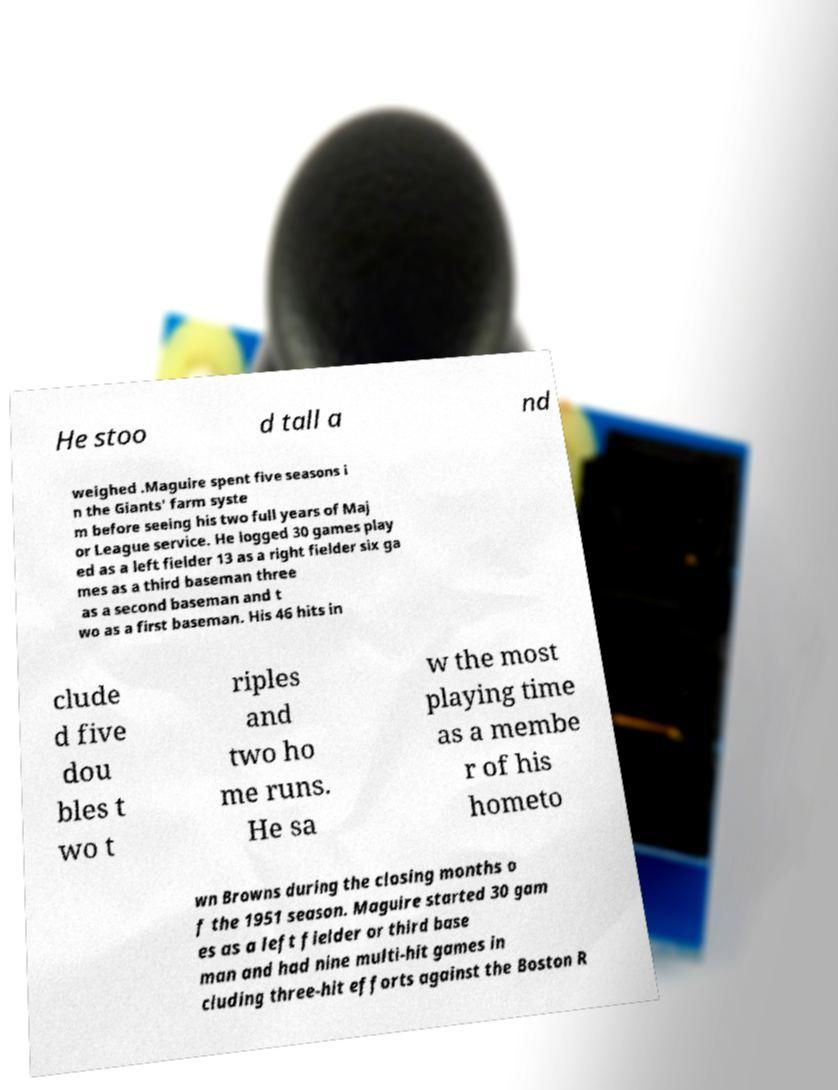What messages or text are displayed in this image? I need them in a readable, typed format. He stoo d tall a nd weighed .Maguire spent five seasons i n the Giants' farm syste m before seeing his two full years of Maj or League service. He logged 30 games play ed as a left fielder 13 as a right fielder six ga mes as a third baseman three as a second baseman and t wo as a first baseman. His 46 hits in clude d five dou bles t wo t riples and two ho me runs. He sa w the most playing time as a membe r of his hometo wn Browns during the closing months o f the 1951 season. Maguire started 30 gam es as a left fielder or third base man and had nine multi-hit games in cluding three-hit efforts against the Boston R 